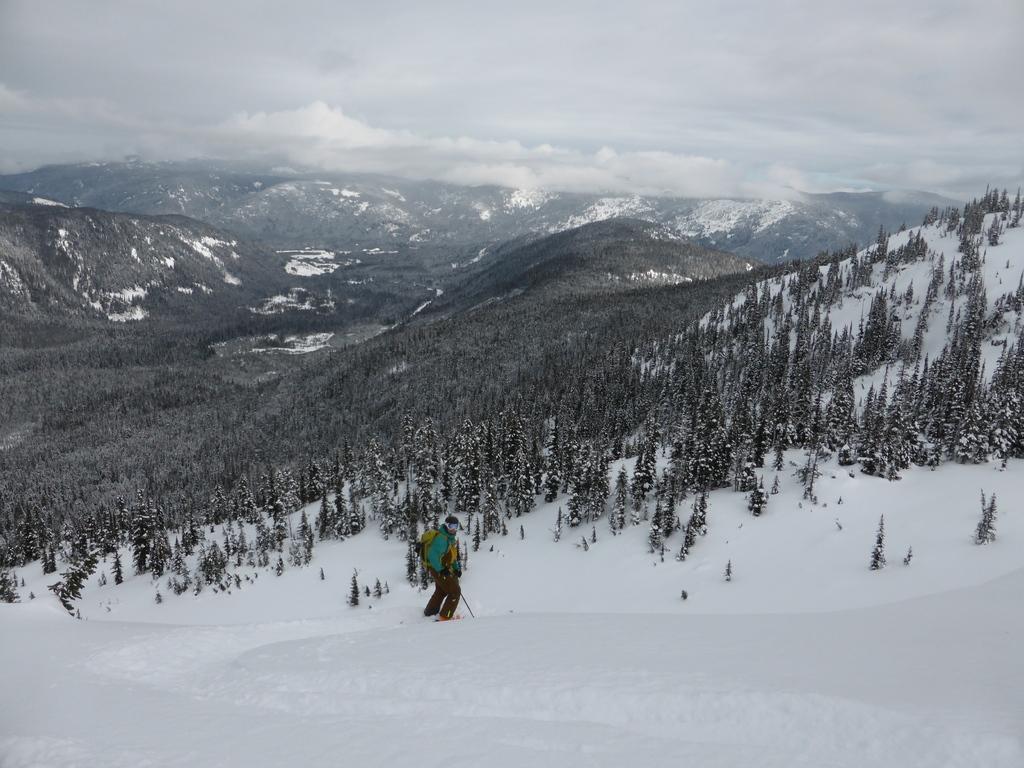Please provide a concise description of this image. In this image we can see a person wearing bag and holding a stick is standing on the snow. In the background we can see group of trees and sky. 